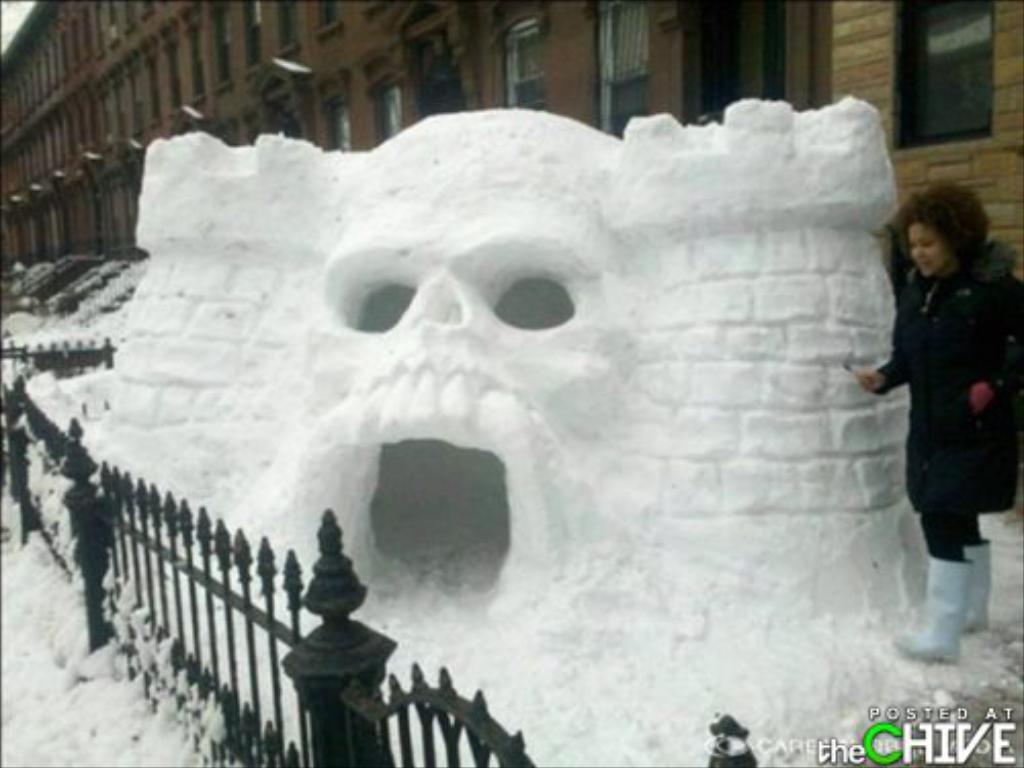Describe this image in one or two sentences. In this picture I can see a person standing, there are iron grilles, there is a skull shaped igloo, there is snow, and in the background there is a building with windows and there are watermarks on the image. 